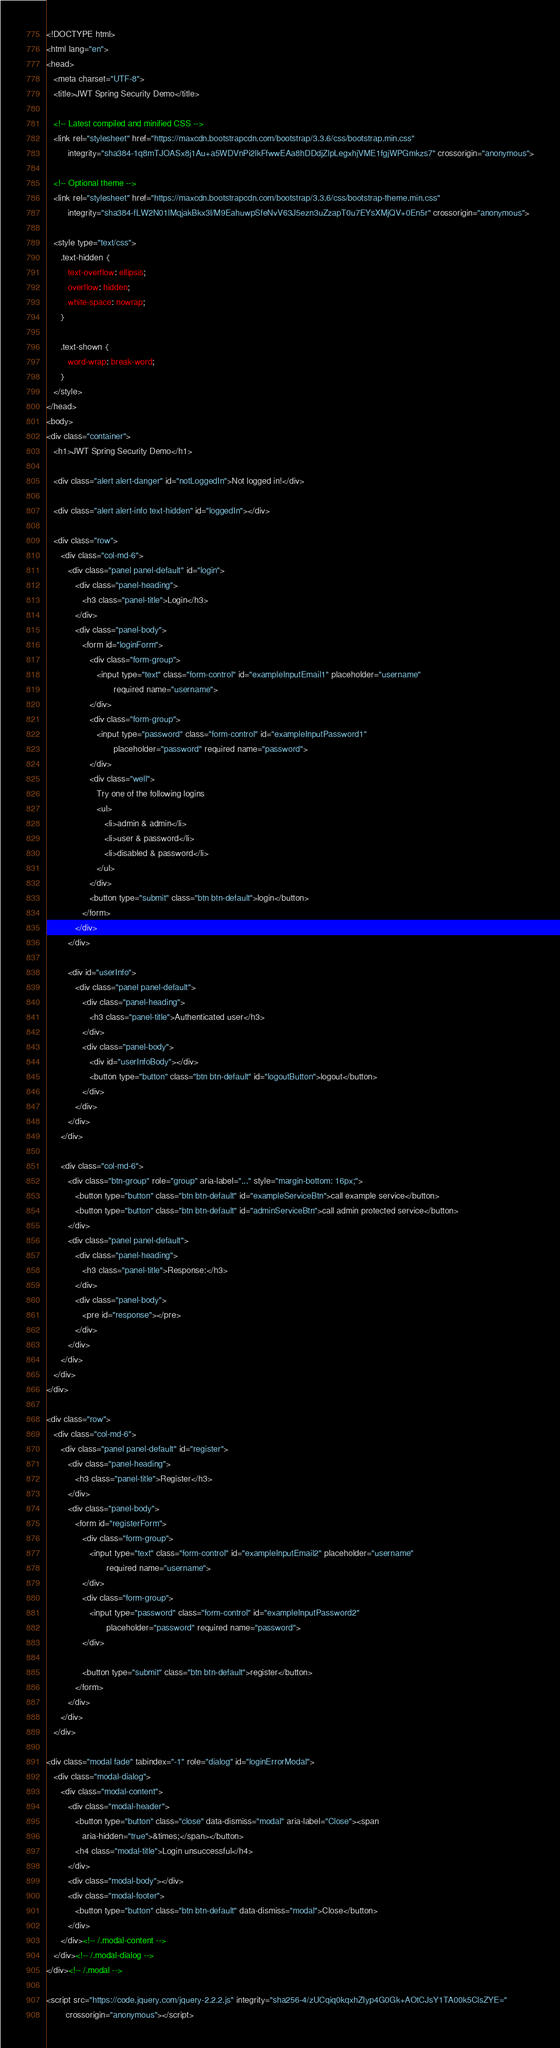Convert code to text. <code><loc_0><loc_0><loc_500><loc_500><_HTML_><!DOCTYPE html>
<html lang="en">
<head>
   <meta charset="UTF-8">
   <title>JWT Spring Security Demo</title>

   <!-- Latest compiled and minified CSS -->
   <link rel="stylesheet" href="https://maxcdn.bootstrapcdn.com/bootstrap/3.3.6/css/bootstrap.min.css"
         integrity="sha384-1q8mTJOASx8j1Au+a5WDVnPi2lkFfwwEAa8hDDdjZlpLegxhjVME1fgjWPGmkzs7" crossorigin="anonymous">

   <!-- Optional theme -->
   <link rel="stylesheet" href="https://maxcdn.bootstrapcdn.com/bootstrap/3.3.6/css/bootstrap-theme.min.css"
         integrity="sha384-fLW2N01lMqjakBkx3l/M9EahuwpSfeNvV63J5ezn3uZzapT0u7EYsXMjQV+0En5r" crossorigin="anonymous">

   <style type="text/css">
      .text-hidden {
         text-overflow: ellipsis;
         overflow: hidden;
         white-space: nowrap;
      }

      .text-shown {
         word-wrap: break-word;
      }
   </style>
</head>
<body>
<div class="container">
   <h1>JWT Spring Security Demo</h1>

   <div class="alert alert-danger" id="notLoggedIn">Not logged in!</div>

   <div class="alert alert-info text-hidden" id="loggedIn"></div>

   <div class="row">
      <div class="col-md-6">
         <div class="panel panel-default" id="login">
            <div class="panel-heading">
               <h3 class="panel-title">Login</h3>
            </div>
            <div class="panel-body">
               <form id="loginForm">
                  <div class="form-group">
                     <input type="text" class="form-control" id="exampleInputEmail1" placeholder="username"
                            required name="username">
                  </div>
                  <div class="form-group">
                     <input type="password" class="form-control" id="exampleInputPassword1"
                            placeholder="password" required name="password">
                  </div>
                  <div class="well">
                     Try one of the following logins
                     <ul>
                        <li>admin & admin</li>
                        <li>user & password</li>
                        <li>disabled & password</li>
                     </ul>
                  </div>
                  <button type="submit" class="btn btn-default">login</button>
               </form>
            </div>
         </div>

         <div id="userInfo">
            <div class="panel panel-default">
               <div class="panel-heading">
                  <h3 class="panel-title">Authenticated user</h3>
               </div>
               <div class="panel-body">
                  <div id="userInfoBody"></div>
                  <button type="button" class="btn btn-default" id="logoutButton">logout</button>
               </div>
            </div>
         </div>
      </div>

      <div class="col-md-6">
         <div class="btn-group" role="group" aria-label="..." style="margin-bottom: 16px;">
            <button type="button" class="btn btn-default" id="exampleServiceBtn">call example service</button>
            <button type="button" class="btn btn-default" id="adminServiceBtn">call admin protected service</button>
         </div>
         <div class="panel panel-default">
            <div class="panel-heading">
               <h3 class="panel-title">Response:</h3>
            </div>
            <div class="panel-body">
               <pre id="response"></pre>
            </div>
         </div>
      </div>
   </div>
</div>

<div class="row">
   <div class="col-md-6">
      <div class="panel panel-default" id="register">
         <div class="panel-heading">
            <h3 class="panel-title">Register</h3>
         </div>
         <div class="panel-body">
            <form id="registerForm">
               <div class="form-group">
                  <input type="text" class="form-control" id="exampleInputEmail2" placeholder="username"
                         required name="username">
               </div>
               <div class="form-group">
                  <input type="password" class="form-control" id="exampleInputPassword2"
                         placeholder="password" required name="password">
               </div>

               <button type="submit" class="btn btn-default">register</button>
            </form>
         </div>
      </div>
   </div>

<div class="modal fade" tabindex="-1" role="dialog" id="loginErrorModal">
   <div class="modal-dialog">
      <div class="modal-content">
         <div class="modal-header">
            <button type="button" class="close" data-dismiss="modal" aria-label="Close"><span
               aria-hidden="true">&times;</span></button>
            <h4 class="modal-title">Login unsuccessful</h4>
         </div>
         <div class="modal-body"></div>
         <div class="modal-footer">
            <button type="button" class="btn btn-default" data-dismiss="modal">Close</button>
         </div>
      </div><!-- /.modal-content -->
   </div><!-- /.modal-dialog -->
</div><!-- /.modal -->

<script src="https://code.jquery.com/jquery-2.2.2.js" integrity="sha256-4/zUCqiq0kqxhZIyp4G0Gk+AOtCJsY1TA00k5ClsZYE="
        crossorigin="anonymous"></script></code> 